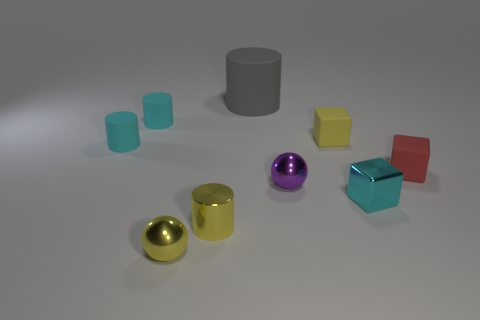Do the purple shiny sphere and the cyan metal cube have the same size?
Keep it short and to the point. Yes. What number of blocks are small red objects or tiny cyan objects?
Give a very brief answer. 2. What number of tiny things are on the left side of the yellow matte block and in front of the red cube?
Give a very brief answer. 3. Is the size of the yellow metal cylinder the same as the block that is in front of the purple shiny ball?
Offer a very short reply. Yes. Is there a yellow ball behind the yellow shiny thing that is behind the ball on the left side of the purple metallic sphere?
Make the answer very short. No. The tiny cyan object that is to the right of the block left of the cyan cube is made of what material?
Keep it short and to the point. Metal. There is a tiny cube that is on the right side of the tiny yellow block and behind the small metallic block; what is it made of?
Make the answer very short. Rubber. Are there any other tiny red things that have the same shape as the tiny red rubber object?
Make the answer very short. No. There is a tiny block in front of the tiny purple thing; are there any yellow spheres that are on the right side of it?
Your answer should be compact. No. How many yellow things are the same material as the gray object?
Offer a terse response. 1. 